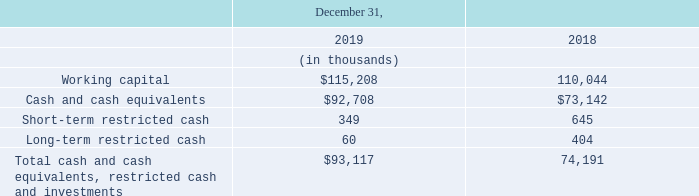Liquidity and Capital Resources
As of December 31, 2019, we had cash and cash equivalents of $92.7 million, restricted cash of $0.4 million, and net accounts receivable of $50.4 million. Additionally, as of December 31, 2019, our working capital was $115.2 million.
Our primary uses of cash are to fund operating expenses, purchases of inventory, property and equipment, intangible assets, and from time to time, the acquisition of businesses. We also use cash to pay down outstanding debt. Our cash and cash equivalents are impacted by the timing of when we pay expenses as reflected in the change in our outstanding accounts payable and accrued expenses.
Cash used to fund operating expenses in our consolidated statements of cash flows excludes the impact of non-cash items such as stock-based compensation, amortization and depreciation of acquired intangible assets, leased right-of-use assets and property and equipment, and impairment of intangible assets and long-lived assets. Cash used to fund acquisitions of businesses and other capital purchases is included in investing activities in our consolidated statements of cash flows.
Our primary sources of cash are cash receipts on accounts receivable from our shipment of products to distributors and direct customers. Aside from the amounts billed to our customers, net cash collections of accounts receivable are impacted by the efficiency of our cash collections process, which can vary from period to period depending on the payment cycles of our major distributor customers, and relative linearity of shipments period-to-period.
Our credit agreement, under which we entered into a term loan to partially fund our acquisition of Exar, permits us to request incremental loans in an aggregate principal amount not to exceed the sum of $160.0 million (subject to adjustments for any voluntary prepayments), plus an unlimited amount that is subject to pro forma compliance with certain secured leverage ratio and total leverage ratio tests. We have not requested any incremental loans to date.
Following is a summary of our working capital, cash and cash equivalents, and restricted cash for the periods indicated:
What is the Long-term restricted cash in 2019?
Answer scale should be: thousand. 60. What is the average Working capital for December 31, 2019 to 2018?
Answer scale should be: thousand. (115,208+110,044) / 2
Answer: 112626. What is the average Cash and cash equivalents for December 31, 2019 to 2018?
Answer scale should be: thousand. (92,708+73,142) / 2
Answer: 82925. In which year was Cash and cash equivalents less than 90,000 thousands? Locate and analyze cash and cash equivalents in row 4
answer: 2018. What was the respective working capital in 2019 and 2018?
Answer scale should be: thousand. 115,208, 110,044. What was the cash and cash equivalents in 2019? $92.7 million. 